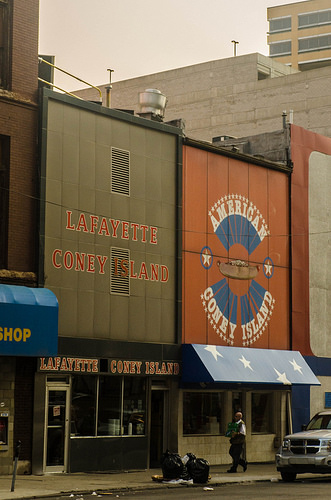<image>
Is the vent in front of the letters? No. The vent is not in front of the letters. The spatial positioning shows a different relationship between these objects. 